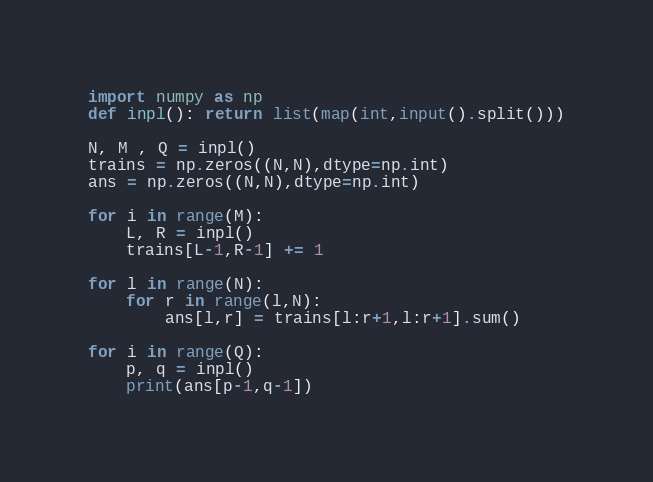<code> <loc_0><loc_0><loc_500><loc_500><_Python_>import numpy as np
def inpl(): return list(map(int,input().split()))

N, M , Q = inpl()
trains = np.zeros((N,N),dtype=np.int)
ans = np.zeros((N,N),dtype=np.int)

for i in range(M):
    L, R = inpl()
    trains[L-1,R-1] += 1

for l in range(N):
    for r in range(l,N):
        ans[l,r] = trains[l:r+1,l:r+1].sum()

for i in range(Q):
    p, q = inpl()
    print(ans[p-1,q-1])</code> 